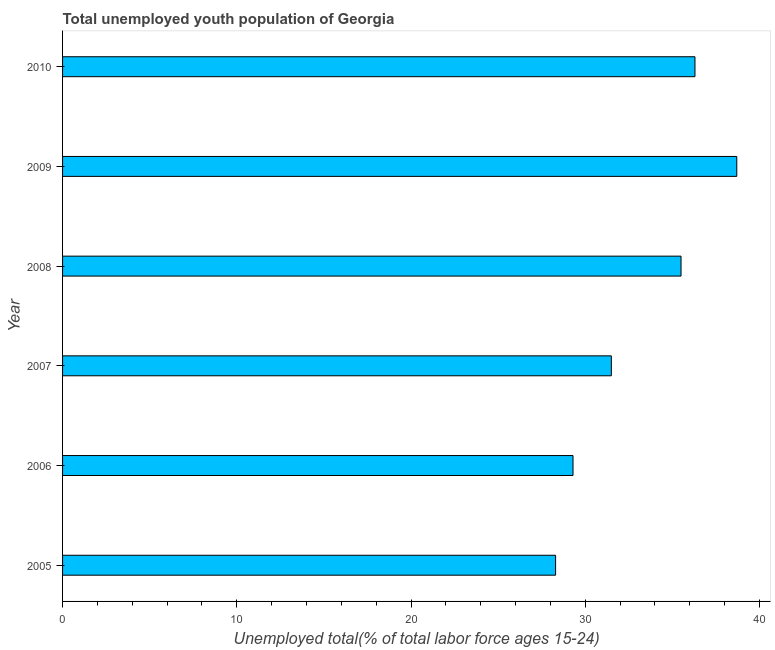Does the graph contain any zero values?
Keep it short and to the point. No. Does the graph contain grids?
Offer a terse response. No. What is the title of the graph?
Your response must be concise. Total unemployed youth population of Georgia. What is the label or title of the X-axis?
Your response must be concise. Unemployed total(% of total labor force ages 15-24). What is the label or title of the Y-axis?
Offer a very short reply. Year. What is the unemployed youth in 2006?
Make the answer very short. 29.3. Across all years, what is the maximum unemployed youth?
Offer a very short reply. 38.7. Across all years, what is the minimum unemployed youth?
Your answer should be very brief. 28.3. In which year was the unemployed youth maximum?
Offer a terse response. 2009. In which year was the unemployed youth minimum?
Offer a very short reply. 2005. What is the sum of the unemployed youth?
Give a very brief answer. 199.6. What is the average unemployed youth per year?
Keep it short and to the point. 33.27. What is the median unemployed youth?
Provide a succinct answer. 33.5. Do a majority of the years between 2009 and 2005 (inclusive) have unemployed youth greater than 8 %?
Offer a very short reply. Yes. What is the ratio of the unemployed youth in 2005 to that in 2009?
Provide a short and direct response. 0.73. Is the difference between the unemployed youth in 2007 and 2010 greater than the difference between any two years?
Your answer should be compact. No. Is the sum of the unemployed youth in 2006 and 2010 greater than the maximum unemployed youth across all years?
Offer a very short reply. Yes. What is the difference between the highest and the lowest unemployed youth?
Provide a short and direct response. 10.4. In how many years, is the unemployed youth greater than the average unemployed youth taken over all years?
Ensure brevity in your answer.  3. Are all the bars in the graph horizontal?
Give a very brief answer. Yes. What is the difference between two consecutive major ticks on the X-axis?
Your answer should be compact. 10. What is the Unemployed total(% of total labor force ages 15-24) of 2005?
Offer a terse response. 28.3. What is the Unemployed total(% of total labor force ages 15-24) of 2006?
Give a very brief answer. 29.3. What is the Unemployed total(% of total labor force ages 15-24) of 2007?
Offer a very short reply. 31.5. What is the Unemployed total(% of total labor force ages 15-24) of 2008?
Ensure brevity in your answer.  35.5. What is the Unemployed total(% of total labor force ages 15-24) in 2009?
Offer a terse response. 38.7. What is the Unemployed total(% of total labor force ages 15-24) in 2010?
Provide a short and direct response. 36.3. What is the difference between the Unemployed total(% of total labor force ages 15-24) in 2005 and 2007?
Provide a short and direct response. -3.2. What is the difference between the Unemployed total(% of total labor force ages 15-24) in 2005 and 2008?
Provide a short and direct response. -7.2. What is the difference between the Unemployed total(% of total labor force ages 15-24) in 2005 and 2010?
Keep it short and to the point. -8. What is the difference between the Unemployed total(% of total labor force ages 15-24) in 2006 and 2007?
Keep it short and to the point. -2.2. What is the difference between the Unemployed total(% of total labor force ages 15-24) in 2006 and 2008?
Provide a short and direct response. -6.2. What is the difference between the Unemployed total(% of total labor force ages 15-24) in 2006 and 2009?
Make the answer very short. -9.4. What is the difference between the Unemployed total(% of total labor force ages 15-24) in 2006 and 2010?
Your answer should be very brief. -7. What is the difference between the Unemployed total(% of total labor force ages 15-24) in 2007 and 2008?
Provide a succinct answer. -4. What is the difference between the Unemployed total(% of total labor force ages 15-24) in 2008 and 2009?
Keep it short and to the point. -3.2. What is the difference between the Unemployed total(% of total labor force ages 15-24) in 2008 and 2010?
Your answer should be compact. -0.8. What is the difference between the Unemployed total(% of total labor force ages 15-24) in 2009 and 2010?
Ensure brevity in your answer.  2.4. What is the ratio of the Unemployed total(% of total labor force ages 15-24) in 2005 to that in 2006?
Your response must be concise. 0.97. What is the ratio of the Unemployed total(% of total labor force ages 15-24) in 2005 to that in 2007?
Your answer should be compact. 0.9. What is the ratio of the Unemployed total(% of total labor force ages 15-24) in 2005 to that in 2008?
Keep it short and to the point. 0.8. What is the ratio of the Unemployed total(% of total labor force ages 15-24) in 2005 to that in 2009?
Ensure brevity in your answer.  0.73. What is the ratio of the Unemployed total(% of total labor force ages 15-24) in 2005 to that in 2010?
Provide a short and direct response. 0.78. What is the ratio of the Unemployed total(% of total labor force ages 15-24) in 2006 to that in 2008?
Make the answer very short. 0.82. What is the ratio of the Unemployed total(% of total labor force ages 15-24) in 2006 to that in 2009?
Ensure brevity in your answer.  0.76. What is the ratio of the Unemployed total(% of total labor force ages 15-24) in 2006 to that in 2010?
Ensure brevity in your answer.  0.81. What is the ratio of the Unemployed total(% of total labor force ages 15-24) in 2007 to that in 2008?
Make the answer very short. 0.89. What is the ratio of the Unemployed total(% of total labor force ages 15-24) in 2007 to that in 2009?
Make the answer very short. 0.81. What is the ratio of the Unemployed total(% of total labor force ages 15-24) in 2007 to that in 2010?
Ensure brevity in your answer.  0.87. What is the ratio of the Unemployed total(% of total labor force ages 15-24) in 2008 to that in 2009?
Make the answer very short. 0.92. What is the ratio of the Unemployed total(% of total labor force ages 15-24) in 2009 to that in 2010?
Offer a terse response. 1.07. 